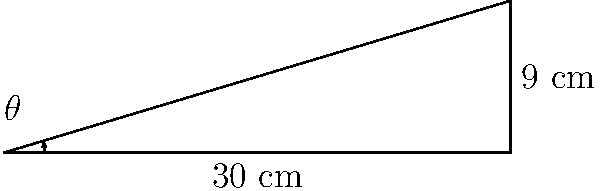You're designing a sloped shelf for your boutique to display products optimally. The shelf is 30 cm deep and rises 9 cm from front to back. What angle $\theta$ should the shelf be tilted at for optimal product visibility? Round your answer to the nearest degree. To solve this problem, we'll use the inverse tangent function (arctangent or $\tan^{-1}$) to find the angle. Here's how:

1) First, identify the sides of the right triangle formed by the shelf:
   - The adjacent side (depth) is 30 cm
   - The opposite side (height) is 9 cm

2) The tangent of an angle is defined as the ratio of the opposite side to the adjacent side:
   
   $\tan(\theta) = \frac{\text{opposite}}{\text{adjacent}} = \frac{9}{30} = 0.3$

3) To find $\theta$, we need to use the inverse tangent function:

   $\theta = \tan^{-1}(0.3)$

4) Using a calculator or computer:

   $\theta \approx 16.70^\circ$

5) Rounding to the nearest degree:

   $\theta \approx 17^\circ$

Therefore, the shelf should be tilted at an angle of approximately 17 degrees for optimal product visibility.
Answer: $17^\circ$ 